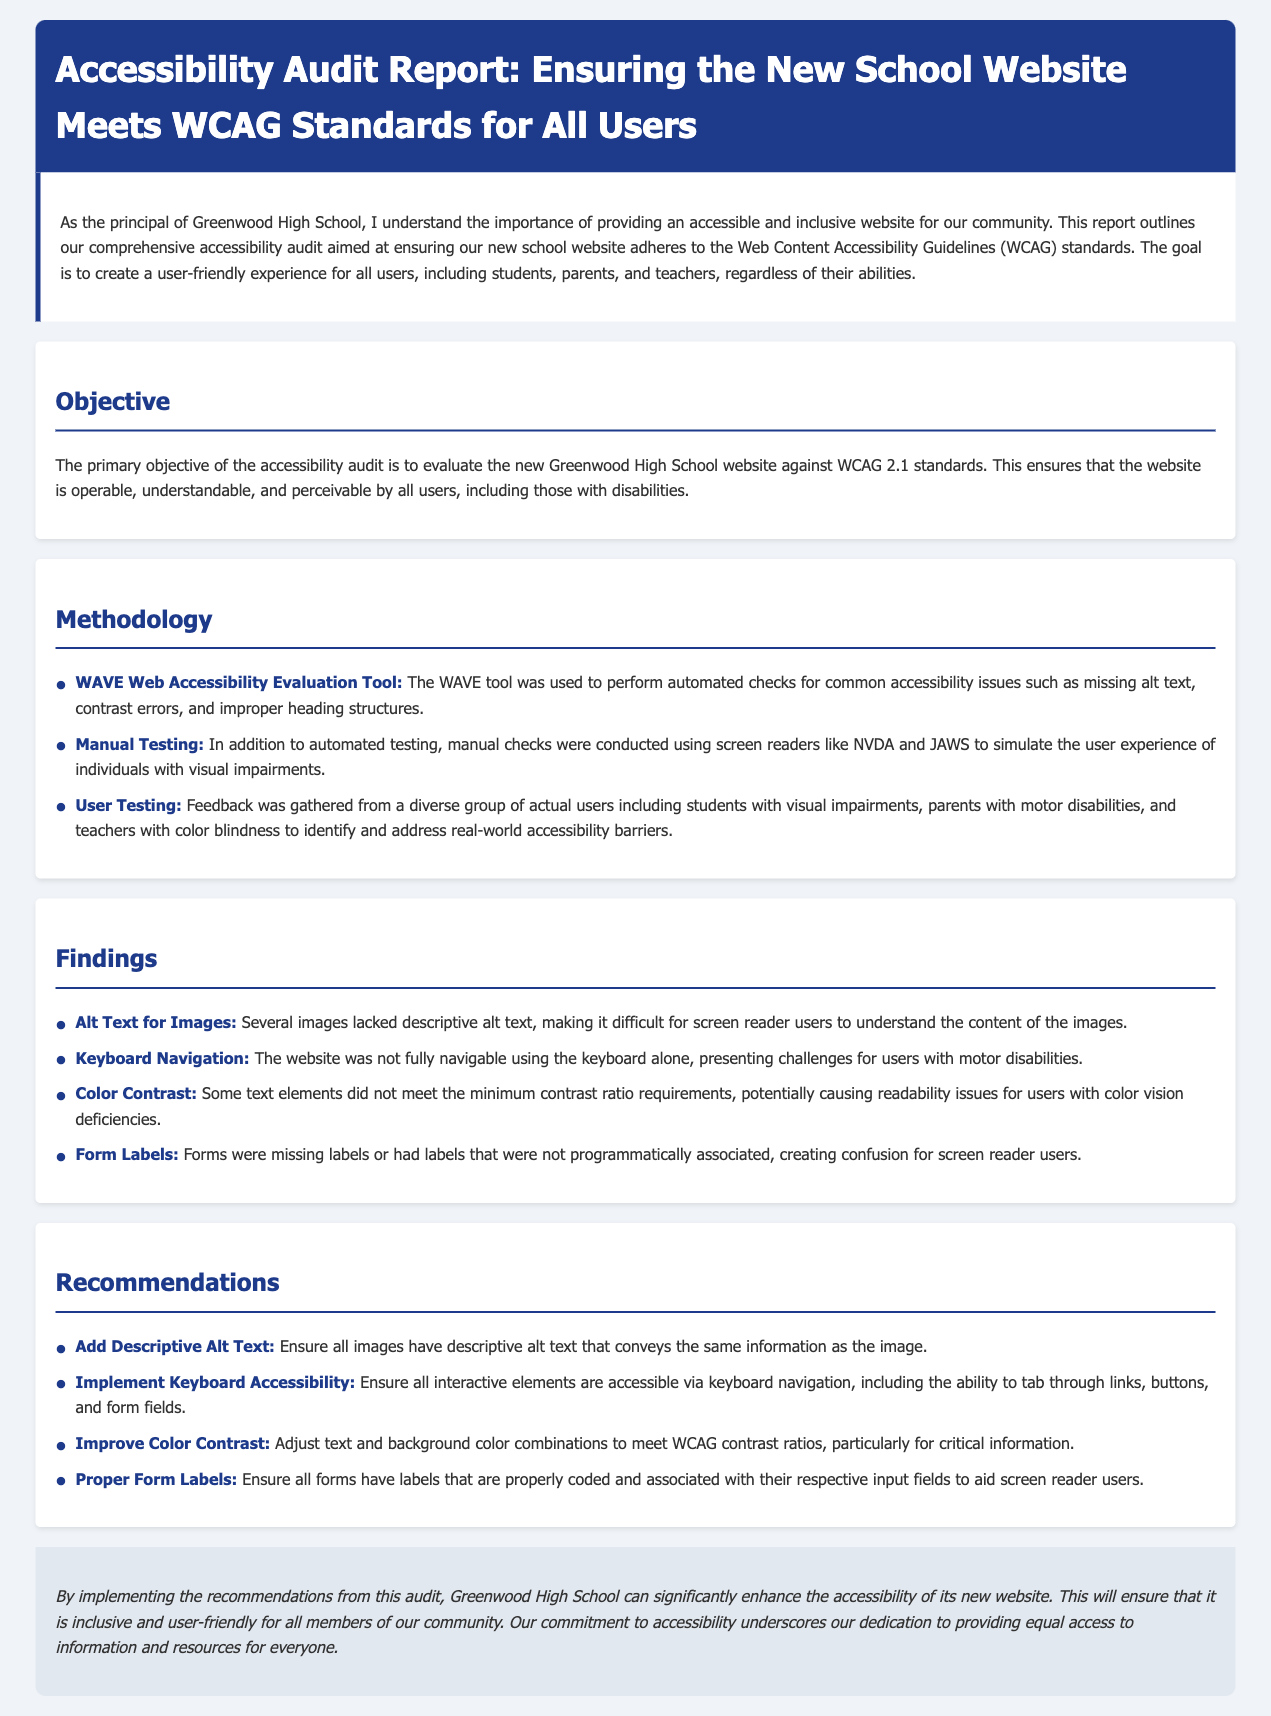What is the title of the report? The title of the report is presented at the top of the document and states its focus on auditing accessibility for the school website.
Answer: Accessibility Audit Report: Ensuring the New School Website Meets WCAG Standards for All Users What is the primary objective of the accessibility audit? The main goal of the audit is highlighted in the section titled "Objective" and emphasizes compliance with WCAG standards.
Answer: Evaluate the new Greenwood High School website against WCAG 2.1 standards Which tool was used for automated accessibility checks? The "Methodology" section details the tools and methods employed, including automated checks.
Answer: WAVE Web Accessibility Evaluation Tool What was one of the issues found during manual testing? The "Findings" section describes specific issues encountered, requiring an understanding of the report's content.
Answer: Alt Text for Images What is one recommendation made in the report? The "Recommendations" section provides actionable steps based on the findings, outlined clearly for implementation.
Answer: Add Descriptive Alt Text How many methods were mentioned for the audit? The number of distinct methodologies used is enumerated in the "Methodology" section, indicating the audit's thoroughness.
Answer: Three What color is used for the background of the report? The document's styling indicates specific colors used in the design, including the background color of the body.
Answer: #f0f4f8 What is the tone used in the conclusion of the report? The conclusion portion expresses a sentiment that reflects the overall aim and dedication of the school towards accessibility.
Answer: Inclusive 